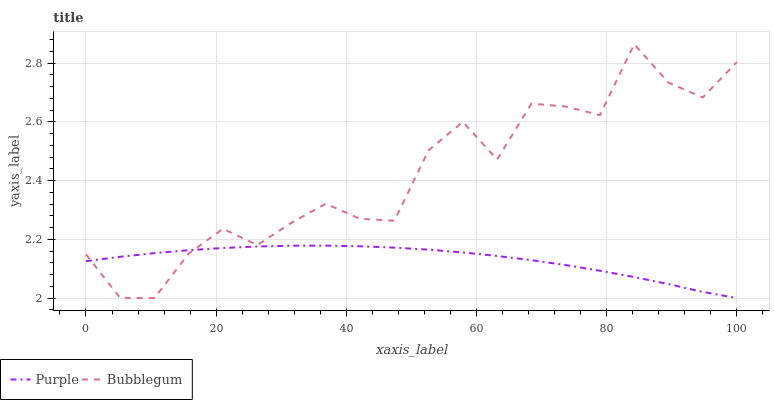Does Purple have the minimum area under the curve?
Answer yes or no. Yes. Does Bubblegum have the maximum area under the curve?
Answer yes or no. Yes. Does Bubblegum have the minimum area under the curve?
Answer yes or no. No. Is Purple the smoothest?
Answer yes or no. Yes. Is Bubblegum the roughest?
Answer yes or no. Yes. Is Bubblegum the smoothest?
Answer yes or no. No. Does Bubblegum have the highest value?
Answer yes or no. Yes. 